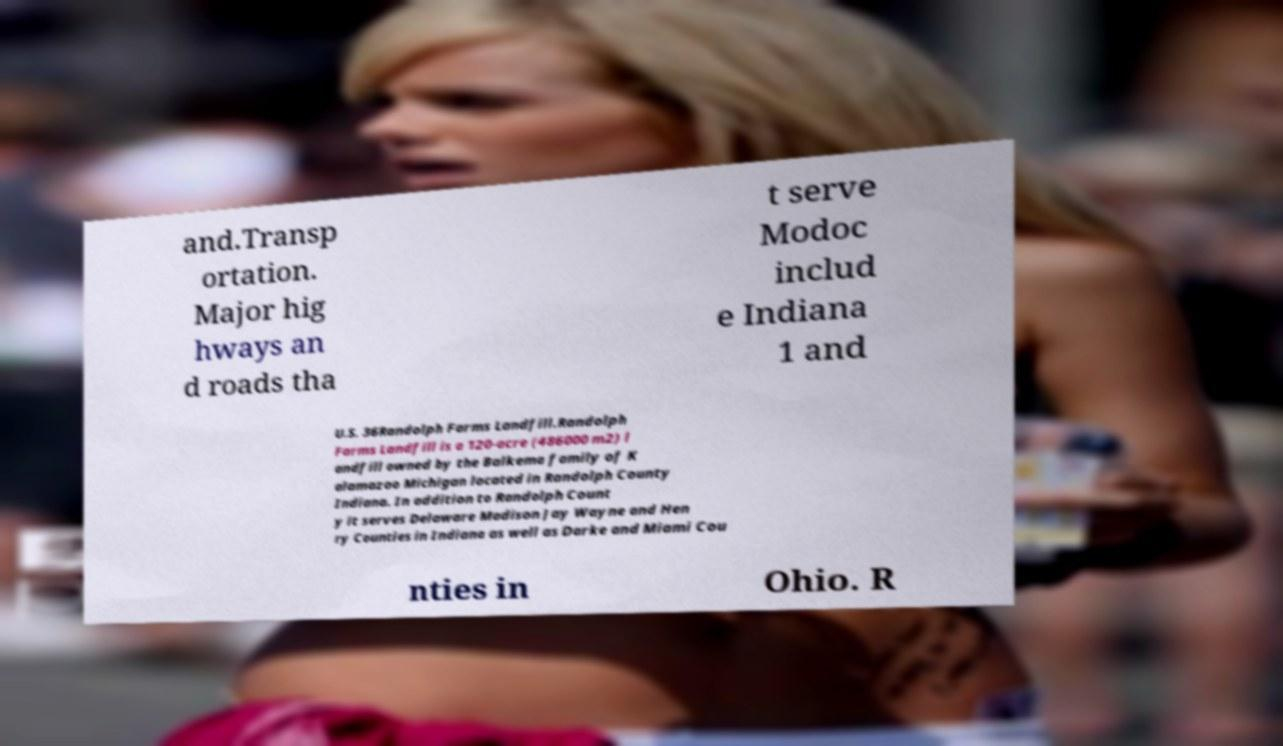I need the written content from this picture converted into text. Can you do that? and.Transp ortation. Major hig hways an d roads tha t serve Modoc includ e Indiana 1 and U.S. 36Randolph Farms Landfill.Randolph Farms Landfill is a 120-acre (486000 m2) l andfill owned by the Balkema family of K alamazoo Michigan located in Randolph County Indiana. In addition to Randolph Count y it serves Delaware Madison Jay Wayne and Hen ry Counties in Indiana as well as Darke and Miami Cou nties in Ohio. R 